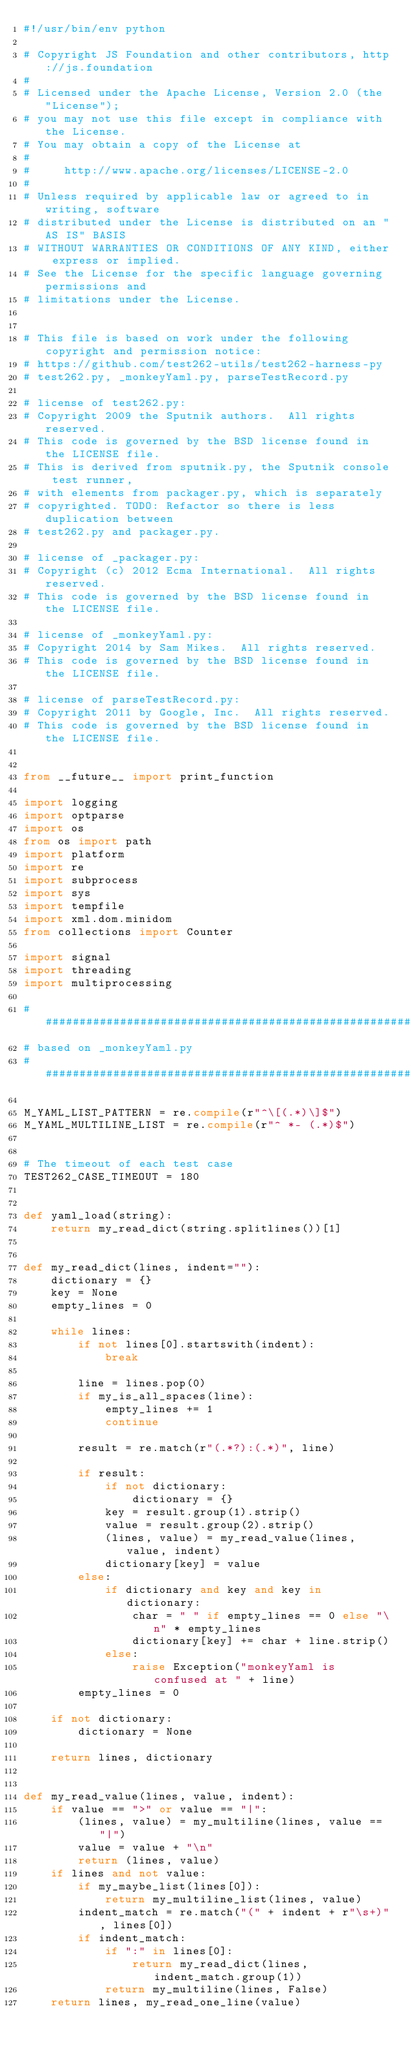Convert code to text. <code><loc_0><loc_0><loc_500><loc_500><_Python_>#!/usr/bin/env python

# Copyright JS Foundation and other contributors, http://js.foundation
#
# Licensed under the Apache License, Version 2.0 (the "License");
# you may not use this file except in compliance with the License.
# You may obtain a copy of the License at
#
#     http://www.apache.org/licenses/LICENSE-2.0
#
# Unless required by applicable law or agreed to in writing, software
# distributed under the License is distributed on an "AS IS" BASIS
# WITHOUT WARRANTIES OR CONDITIONS OF ANY KIND, either express or implied.
# See the License for the specific language governing permissions and
# limitations under the License.


# This file is based on work under the following copyright and permission notice:
# https://github.com/test262-utils/test262-harness-py
# test262.py, _monkeyYaml.py, parseTestRecord.py

# license of test262.py:
# Copyright 2009 the Sputnik authors.  All rights reserved.
# This code is governed by the BSD license found in the LICENSE file.
# This is derived from sputnik.py, the Sputnik console test runner,
# with elements from packager.py, which is separately
# copyrighted. TODO: Refactor so there is less duplication between
# test262.py and packager.py.

# license of _packager.py:
# Copyright (c) 2012 Ecma International.  All rights reserved.
# This code is governed by the BSD license found in the LICENSE file.

# license of _monkeyYaml.py:
# Copyright 2014 by Sam Mikes.  All rights reserved.
# This code is governed by the BSD license found in the LICENSE file.

# license of parseTestRecord.py:
# Copyright 2011 by Google, Inc.  All rights reserved.
# This code is governed by the BSD license found in the LICENSE file.


from __future__ import print_function

import logging
import optparse
import os
from os import path
import platform
import re
import subprocess
import sys
import tempfile
import xml.dom.minidom
from collections import Counter

import signal
import threading
import multiprocessing

#######################################################################
# based on _monkeyYaml.py
#######################################################################

M_YAML_LIST_PATTERN = re.compile(r"^\[(.*)\]$")
M_YAML_MULTILINE_LIST = re.compile(r"^ *- (.*)$")


# The timeout of each test case
TEST262_CASE_TIMEOUT = 180


def yaml_load(string):
    return my_read_dict(string.splitlines())[1]


def my_read_dict(lines, indent=""):
    dictionary = {}
    key = None
    empty_lines = 0

    while lines:
        if not lines[0].startswith(indent):
            break

        line = lines.pop(0)
        if my_is_all_spaces(line):
            empty_lines += 1
            continue

        result = re.match(r"(.*?):(.*)", line)

        if result:
            if not dictionary:
                dictionary = {}
            key = result.group(1).strip()
            value = result.group(2).strip()
            (lines, value) = my_read_value(lines, value, indent)
            dictionary[key] = value
        else:
            if dictionary and key and key in dictionary:
                char = " " if empty_lines == 0 else "\n" * empty_lines
                dictionary[key] += char + line.strip()
            else:
                raise Exception("monkeyYaml is confused at " + line)
        empty_lines = 0

    if not dictionary:
        dictionary = None

    return lines, dictionary


def my_read_value(lines, value, indent):
    if value == ">" or value == "|":
        (lines, value) = my_multiline(lines, value == "|")
        value = value + "\n"
        return (lines, value)
    if lines and not value:
        if my_maybe_list(lines[0]):
            return my_multiline_list(lines, value)
        indent_match = re.match("(" + indent + r"\s+)", lines[0])
        if indent_match:
            if ":" in lines[0]:
                return my_read_dict(lines, indent_match.group(1))
            return my_multiline(lines, False)
    return lines, my_read_one_line(value)

</code> 